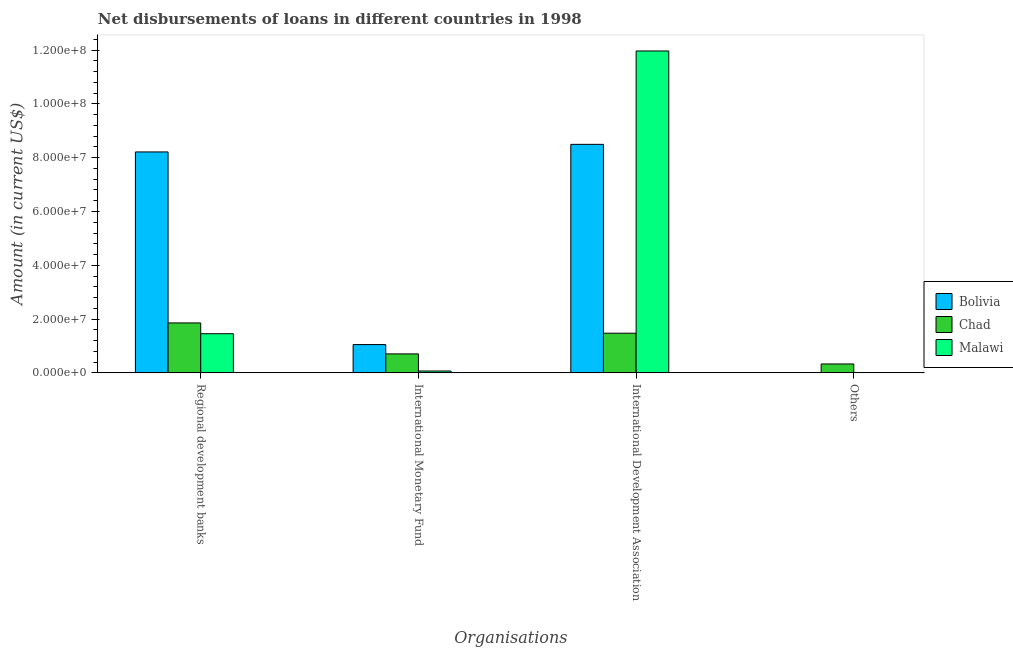Are the number of bars per tick equal to the number of legend labels?
Keep it short and to the point. No. What is the label of the 1st group of bars from the left?
Keep it short and to the point. Regional development banks. What is the amount of loan disimbursed by international development association in Malawi?
Offer a terse response. 1.20e+08. Across all countries, what is the maximum amount of loan disimbursed by international monetary fund?
Your answer should be compact. 1.05e+07. Across all countries, what is the minimum amount of loan disimbursed by international development association?
Offer a terse response. 1.47e+07. In which country was the amount of loan disimbursed by other organisations maximum?
Offer a terse response. Chad. What is the total amount of loan disimbursed by international monetary fund in the graph?
Keep it short and to the point. 1.83e+07. What is the difference between the amount of loan disimbursed by international monetary fund in Bolivia and that in Malawi?
Make the answer very short. 9.83e+06. What is the difference between the amount of loan disimbursed by international development association in Malawi and the amount of loan disimbursed by regional development banks in Bolivia?
Your answer should be very brief. 3.75e+07. What is the average amount of loan disimbursed by international monetary fund per country?
Ensure brevity in your answer.  6.09e+06. What is the difference between the amount of loan disimbursed by international monetary fund and amount of loan disimbursed by other organisations in Chad?
Make the answer very short. 3.75e+06. What is the ratio of the amount of loan disimbursed by regional development banks in Bolivia to that in Malawi?
Your answer should be compact. 5.64. Is the amount of loan disimbursed by international monetary fund in Chad less than that in Bolivia?
Keep it short and to the point. Yes. Is the difference between the amount of loan disimbursed by international development association in Chad and Malawi greater than the difference between the amount of loan disimbursed by regional development banks in Chad and Malawi?
Your answer should be very brief. No. What is the difference between the highest and the second highest amount of loan disimbursed by international development association?
Keep it short and to the point. 3.47e+07. What is the difference between the highest and the lowest amount of loan disimbursed by international monetary fund?
Provide a succinct answer. 9.83e+06. Is it the case that in every country, the sum of the amount of loan disimbursed by international monetary fund and amount of loan disimbursed by international development association is greater than the sum of amount of loan disimbursed by other organisations and amount of loan disimbursed by regional development banks?
Offer a terse response. No. Is it the case that in every country, the sum of the amount of loan disimbursed by regional development banks and amount of loan disimbursed by international monetary fund is greater than the amount of loan disimbursed by international development association?
Give a very brief answer. No. How many bars are there?
Your response must be concise. 10. Are all the bars in the graph horizontal?
Provide a short and direct response. No. How many countries are there in the graph?
Provide a short and direct response. 3. Are the values on the major ticks of Y-axis written in scientific E-notation?
Offer a very short reply. Yes. Does the graph contain grids?
Keep it short and to the point. No. What is the title of the graph?
Ensure brevity in your answer.  Net disbursements of loans in different countries in 1998. Does "Nigeria" appear as one of the legend labels in the graph?
Provide a succinct answer. No. What is the label or title of the X-axis?
Your answer should be very brief. Organisations. What is the Amount (in current US$) in Bolivia in Regional development banks?
Ensure brevity in your answer.  8.21e+07. What is the Amount (in current US$) of Chad in Regional development banks?
Give a very brief answer. 1.86e+07. What is the Amount (in current US$) of Malawi in Regional development banks?
Provide a short and direct response. 1.46e+07. What is the Amount (in current US$) in Bolivia in International Monetary Fund?
Provide a short and direct response. 1.05e+07. What is the Amount (in current US$) of Chad in International Monetary Fund?
Your answer should be compact. 7.06e+06. What is the Amount (in current US$) in Malawi in International Monetary Fund?
Your answer should be compact. 6.90e+05. What is the Amount (in current US$) in Bolivia in International Development Association?
Offer a terse response. 8.50e+07. What is the Amount (in current US$) of Chad in International Development Association?
Make the answer very short. 1.47e+07. What is the Amount (in current US$) in Malawi in International Development Association?
Your response must be concise. 1.20e+08. What is the Amount (in current US$) in Chad in Others?
Make the answer very short. 3.31e+06. Across all Organisations, what is the maximum Amount (in current US$) in Bolivia?
Provide a short and direct response. 8.50e+07. Across all Organisations, what is the maximum Amount (in current US$) in Chad?
Offer a very short reply. 1.86e+07. Across all Organisations, what is the maximum Amount (in current US$) of Malawi?
Make the answer very short. 1.20e+08. Across all Organisations, what is the minimum Amount (in current US$) in Bolivia?
Provide a succinct answer. 0. Across all Organisations, what is the minimum Amount (in current US$) of Chad?
Your answer should be compact. 3.31e+06. Across all Organisations, what is the minimum Amount (in current US$) of Malawi?
Provide a succinct answer. 0. What is the total Amount (in current US$) of Bolivia in the graph?
Keep it short and to the point. 1.78e+08. What is the total Amount (in current US$) of Chad in the graph?
Give a very brief answer. 4.37e+07. What is the total Amount (in current US$) of Malawi in the graph?
Ensure brevity in your answer.  1.35e+08. What is the difference between the Amount (in current US$) in Bolivia in Regional development banks and that in International Monetary Fund?
Provide a succinct answer. 7.16e+07. What is the difference between the Amount (in current US$) of Chad in Regional development banks and that in International Monetary Fund?
Give a very brief answer. 1.15e+07. What is the difference between the Amount (in current US$) of Malawi in Regional development banks and that in International Monetary Fund?
Your answer should be compact. 1.39e+07. What is the difference between the Amount (in current US$) of Bolivia in Regional development banks and that in International Development Association?
Ensure brevity in your answer.  -2.82e+06. What is the difference between the Amount (in current US$) in Chad in Regional development banks and that in International Development Association?
Keep it short and to the point. 3.82e+06. What is the difference between the Amount (in current US$) in Malawi in Regional development banks and that in International Development Association?
Offer a terse response. -1.05e+08. What is the difference between the Amount (in current US$) in Chad in Regional development banks and that in Others?
Keep it short and to the point. 1.53e+07. What is the difference between the Amount (in current US$) of Bolivia in International Monetary Fund and that in International Development Association?
Ensure brevity in your answer.  -7.44e+07. What is the difference between the Amount (in current US$) in Chad in International Monetary Fund and that in International Development Association?
Provide a succinct answer. -7.69e+06. What is the difference between the Amount (in current US$) in Malawi in International Monetary Fund and that in International Development Association?
Keep it short and to the point. -1.19e+08. What is the difference between the Amount (in current US$) in Chad in International Monetary Fund and that in Others?
Keep it short and to the point. 3.75e+06. What is the difference between the Amount (in current US$) of Chad in International Development Association and that in Others?
Give a very brief answer. 1.14e+07. What is the difference between the Amount (in current US$) in Bolivia in Regional development banks and the Amount (in current US$) in Chad in International Monetary Fund?
Your answer should be very brief. 7.51e+07. What is the difference between the Amount (in current US$) of Bolivia in Regional development banks and the Amount (in current US$) of Malawi in International Monetary Fund?
Provide a short and direct response. 8.15e+07. What is the difference between the Amount (in current US$) of Chad in Regional development banks and the Amount (in current US$) of Malawi in International Monetary Fund?
Offer a very short reply. 1.79e+07. What is the difference between the Amount (in current US$) in Bolivia in Regional development banks and the Amount (in current US$) in Chad in International Development Association?
Ensure brevity in your answer.  6.74e+07. What is the difference between the Amount (in current US$) in Bolivia in Regional development banks and the Amount (in current US$) in Malawi in International Development Association?
Provide a succinct answer. -3.75e+07. What is the difference between the Amount (in current US$) in Chad in Regional development banks and the Amount (in current US$) in Malawi in International Development Association?
Ensure brevity in your answer.  -1.01e+08. What is the difference between the Amount (in current US$) of Bolivia in Regional development banks and the Amount (in current US$) of Chad in Others?
Give a very brief answer. 7.88e+07. What is the difference between the Amount (in current US$) in Bolivia in International Monetary Fund and the Amount (in current US$) in Chad in International Development Association?
Make the answer very short. -4.22e+06. What is the difference between the Amount (in current US$) of Bolivia in International Monetary Fund and the Amount (in current US$) of Malawi in International Development Association?
Provide a succinct answer. -1.09e+08. What is the difference between the Amount (in current US$) in Chad in International Monetary Fund and the Amount (in current US$) in Malawi in International Development Association?
Provide a succinct answer. -1.13e+08. What is the difference between the Amount (in current US$) of Bolivia in International Monetary Fund and the Amount (in current US$) of Chad in Others?
Offer a very short reply. 7.21e+06. What is the difference between the Amount (in current US$) in Bolivia in International Development Association and the Amount (in current US$) in Chad in Others?
Your answer should be compact. 8.17e+07. What is the average Amount (in current US$) of Bolivia per Organisations?
Your answer should be very brief. 4.44e+07. What is the average Amount (in current US$) of Chad per Organisations?
Your answer should be very brief. 1.09e+07. What is the average Amount (in current US$) of Malawi per Organisations?
Keep it short and to the point. 3.37e+07. What is the difference between the Amount (in current US$) in Bolivia and Amount (in current US$) in Chad in Regional development banks?
Give a very brief answer. 6.36e+07. What is the difference between the Amount (in current US$) in Bolivia and Amount (in current US$) in Malawi in Regional development banks?
Give a very brief answer. 6.76e+07. What is the difference between the Amount (in current US$) of Chad and Amount (in current US$) of Malawi in Regional development banks?
Offer a terse response. 4.01e+06. What is the difference between the Amount (in current US$) in Bolivia and Amount (in current US$) in Chad in International Monetary Fund?
Offer a very short reply. 3.46e+06. What is the difference between the Amount (in current US$) in Bolivia and Amount (in current US$) in Malawi in International Monetary Fund?
Make the answer very short. 9.83e+06. What is the difference between the Amount (in current US$) in Chad and Amount (in current US$) in Malawi in International Monetary Fund?
Your answer should be compact. 6.36e+06. What is the difference between the Amount (in current US$) of Bolivia and Amount (in current US$) of Chad in International Development Association?
Provide a succinct answer. 7.02e+07. What is the difference between the Amount (in current US$) of Bolivia and Amount (in current US$) of Malawi in International Development Association?
Make the answer very short. -3.47e+07. What is the difference between the Amount (in current US$) of Chad and Amount (in current US$) of Malawi in International Development Association?
Give a very brief answer. -1.05e+08. What is the ratio of the Amount (in current US$) in Bolivia in Regional development banks to that in International Monetary Fund?
Provide a short and direct response. 7.81. What is the ratio of the Amount (in current US$) in Chad in Regional development banks to that in International Monetary Fund?
Your response must be concise. 2.63. What is the ratio of the Amount (in current US$) of Malawi in Regional development banks to that in International Monetary Fund?
Offer a terse response. 21.1. What is the ratio of the Amount (in current US$) of Bolivia in Regional development banks to that in International Development Association?
Make the answer very short. 0.97. What is the ratio of the Amount (in current US$) in Chad in Regional development banks to that in International Development Association?
Your answer should be very brief. 1.26. What is the ratio of the Amount (in current US$) of Malawi in Regional development banks to that in International Development Association?
Make the answer very short. 0.12. What is the ratio of the Amount (in current US$) in Chad in Regional development banks to that in Others?
Your answer should be very brief. 5.61. What is the ratio of the Amount (in current US$) of Bolivia in International Monetary Fund to that in International Development Association?
Offer a very short reply. 0.12. What is the ratio of the Amount (in current US$) of Chad in International Monetary Fund to that in International Development Association?
Provide a succinct answer. 0.48. What is the ratio of the Amount (in current US$) in Malawi in International Monetary Fund to that in International Development Association?
Keep it short and to the point. 0.01. What is the ratio of the Amount (in current US$) in Chad in International Monetary Fund to that in Others?
Your answer should be very brief. 2.13. What is the ratio of the Amount (in current US$) of Chad in International Development Association to that in Others?
Keep it short and to the point. 4.46. What is the difference between the highest and the second highest Amount (in current US$) of Bolivia?
Offer a terse response. 2.82e+06. What is the difference between the highest and the second highest Amount (in current US$) of Chad?
Give a very brief answer. 3.82e+06. What is the difference between the highest and the second highest Amount (in current US$) of Malawi?
Your response must be concise. 1.05e+08. What is the difference between the highest and the lowest Amount (in current US$) in Bolivia?
Keep it short and to the point. 8.50e+07. What is the difference between the highest and the lowest Amount (in current US$) of Chad?
Provide a short and direct response. 1.53e+07. What is the difference between the highest and the lowest Amount (in current US$) in Malawi?
Provide a succinct answer. 1.20e+08. 